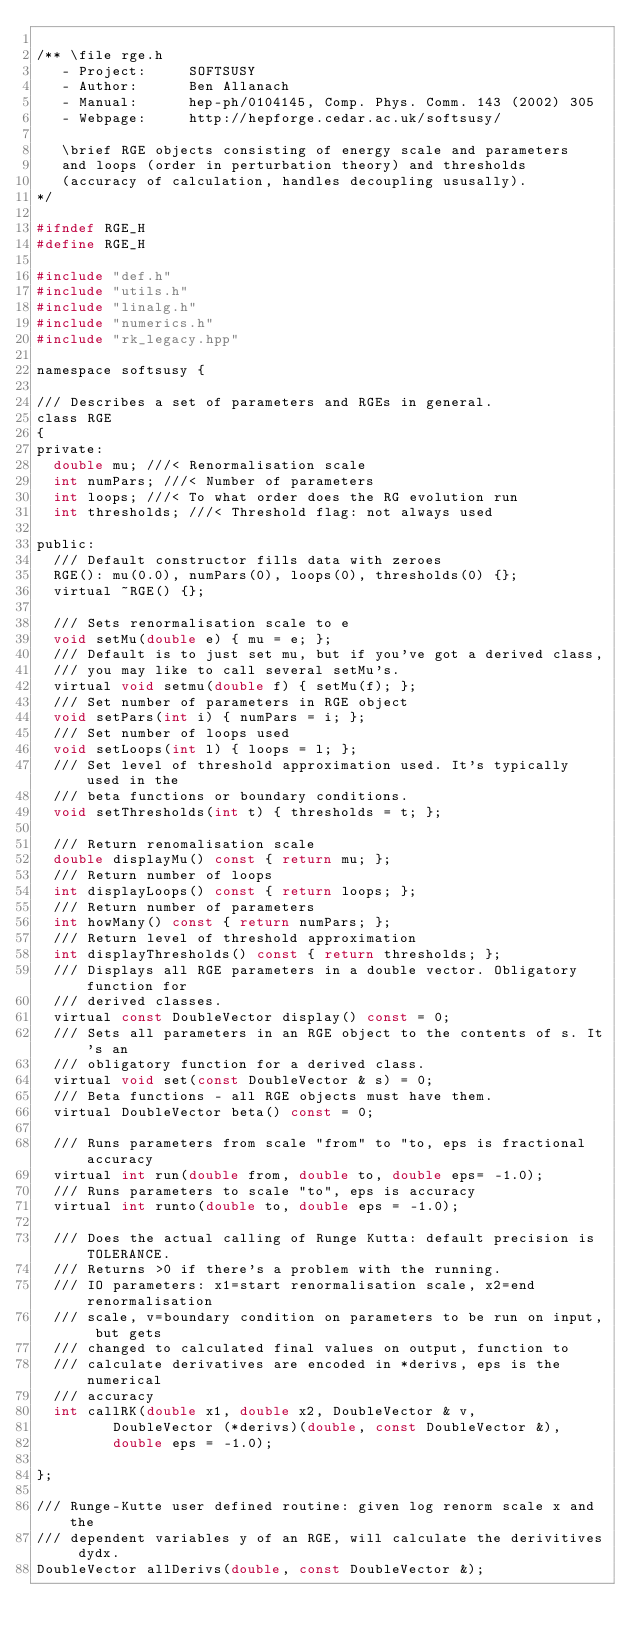<code> <loc_0><loc_0><loc_500><loc_500><_C_>
/** \file rge.h
   - Project:     SOFTSUSY
   - Author:      Ben Allanach 
   - Manual:      hep-ph/0104145, Comp. Phys. Comm. 143 (2002) 305 
   - Webpage:     http://hepforge.cedar.ac.uk/softsusy/

   \brief RGE objects consisting of energy scale and parameters 
   and loops (order in perturbation theory) and thresholds
   (accuracy of calculation, handles decoupling ususally).
*/

#ifndef RGE_H
#define RGE_H

#include "def.h"
#include "utils.h"
#include "linalg.h"
#include "numerics.h"
#include "rk_legacy.hpp"

namespace softsusy {

/// Describes a set of parameters and RGEs in general. 
class RGE
{
private:
  double mu; ///< Renormalisation scale
  int numPars; ///< Number of parameters
  int loops; ///< To what order does the RG evolution run
  int thresholds; ///< Threshold flag: not always used

public:
  /// Default constructor fills data with zeroes
  RGE(): mu(0.0), numPars(0), loops(0), thresholds(0) {};
  virtual ~RGE() {};
  
  /// Sets renormalisation scale to e
  void setMu(double e) { mu = e; };
  /// Default is to just set mu, but if you've got a derived class, 
  /// you may like to call several setMu's.
  virtual void setmu(double f) { setMu(f); };
  /// Set number of parameters in RGE object
  void setPars(int i) { numPars = i; };
  /// Set number of loops used
  void setLoops(int l) { loops = l; };
  /// Set level of threshold approximation used. It's typically used in the
  /// beta functions or boundary conditions.
  void setThresholds(int t) { thresholds = t; };

  /// Return renomalisation scale
  double displayMu() const { return mu; };
  /// Return number of loops
  int displayLoops() const { return loops; };
  /// Return number of parameters
  int howMany() const { return numPars; };
  /// Return level of threshold approximation
  int displayThresholds() const { return thresholds; };  
  /// Displays all RGE parameters in a double vector. Obligatory function for
  /// derived classes.
  virtual const DoubleVector display() const = 0;
  /// Sets all parameters in an RGE object to the contents of s. It's an
  /// obligatory function for a derived class.
  virtual void set(const DoubleVector & s) = 0;
  /// Beta functions - all RGE objects must have them.
  virtual DoubleVector beta() const = 0;

  /// Runs parameters from scale "from" to "to, eps is fractional accuracy
  virtual int run(double from, double to, double eps= -1.0);
  /// Runs parameters to scale "to", eps is accuracy
  virtual int runto(double to, double eps = -1.0);
  
  /// Does the actual calling of Runge Kutta: default precision is TOLERANCE.
  /// Returns >0 if there's a problem with the running.
  /// IO parameters: x1=start renormalisation scale, x2=end renormalisation
  /// scale, v=boundary condition on parameters to be run on input, but gets
  /// changed to calculated final values on output, function to
  /// calculate derivatives are encoded in *derivs, eps is the numerical
  /// accuracy 
  int callRK(double x1, double x2, DoubleVector & v, 
	     DoubleVector (*derivs)(double, const DoubleVector &), 
	     double eps = -1.0);

};  

/// Runge-Kutte user defined routine: given log renorm scale x and the
/// dependent variables y of an RGE, will calculate the derivitives dydx.
DoubleVector allDerivs(double, const DoubleVector &);
</code> 